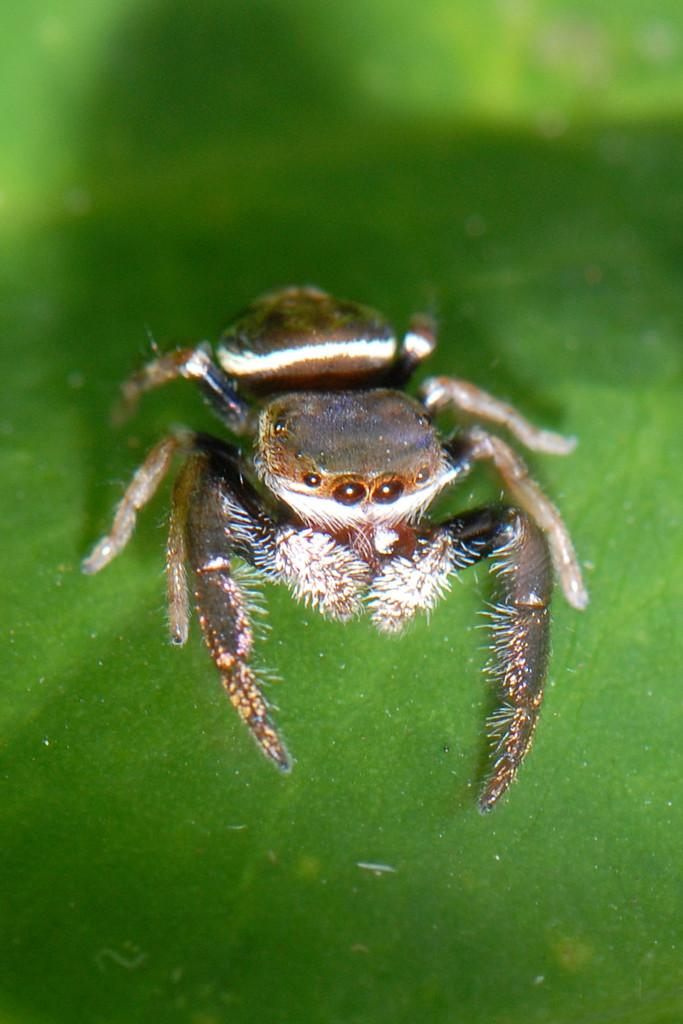What is the main subject of the image? There is a spider in the image. Can you describe the spider's appearance? The spider has black, brown, and white coloring. What is the spider resting on in the image? The spider is on a green-colored object. How would you describe the background of the image? The background of the image is blurry. What type of coat is the spider wearing in the image? There is no coat present in the image, as spiders do not wear clothing. 